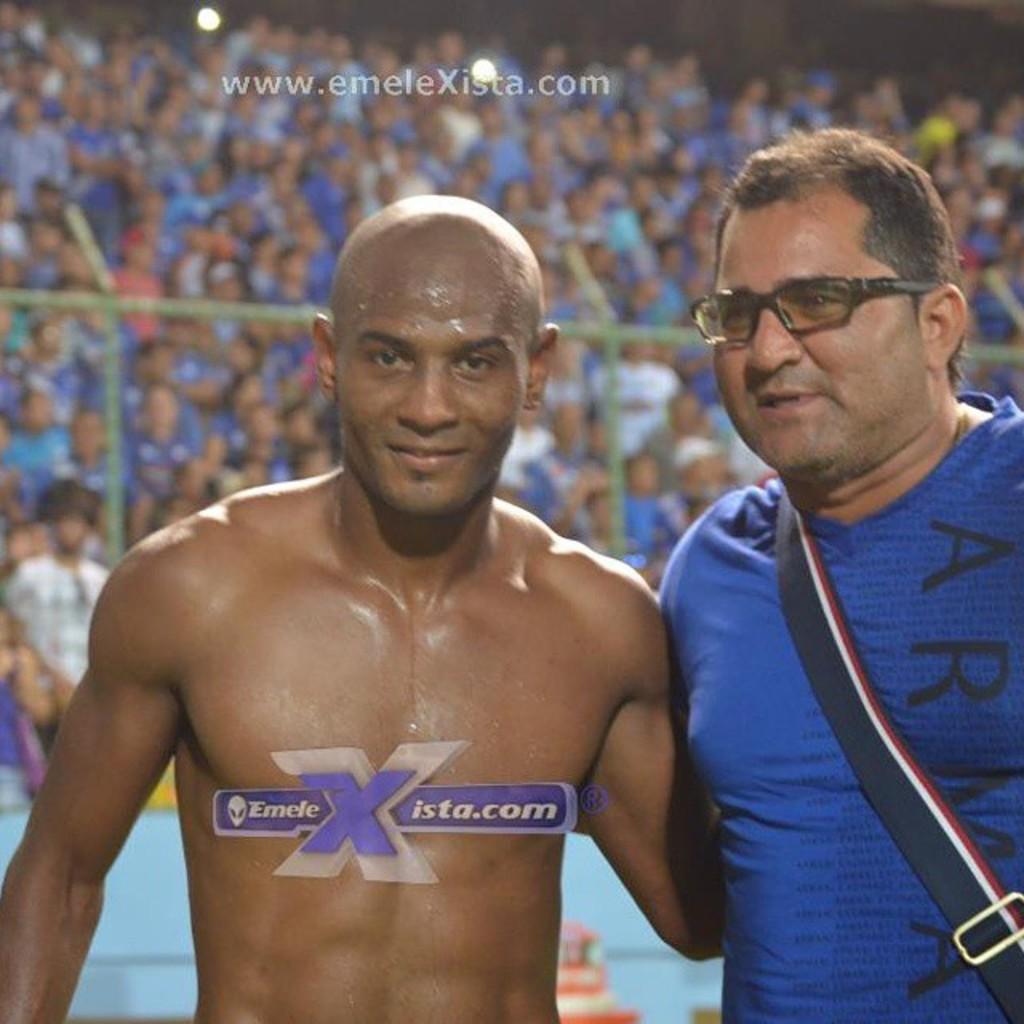<image>
Offer a succinct explanation of the picture presented. A picture of a shirtless man next to a man wearing glasses and the website address of www.emelexista.com on it. 